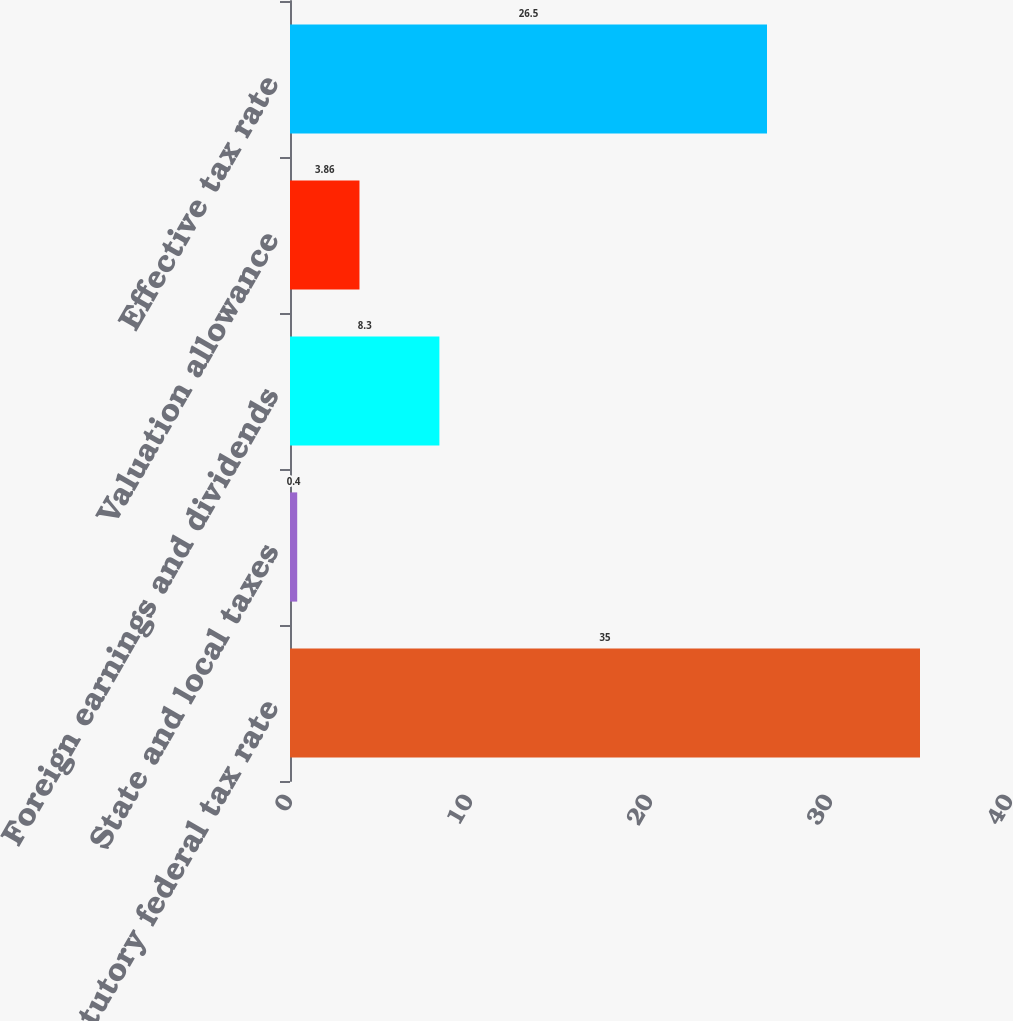Convert chart. <chart><loc_0><loc_0><loc_500><loc_500><bar_chart><fcel>US statutory federal tax rate<fcel>State and local taxes<fcel>Foreign earnings and dividends<fcel>Valuation allowance<fcel>Effective tax rate<nl><fcel>35<fcel>0.4<fcel>8.3<fcel>3.86<fcel>26.5<nl></chart> 